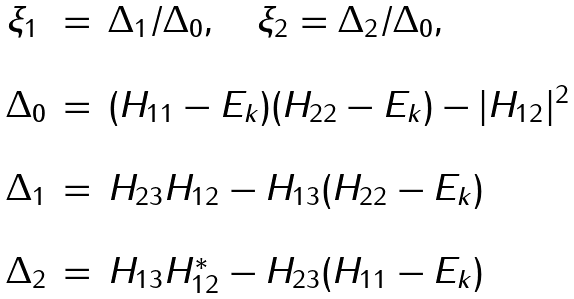Convert formula to latex. <formula><loc_0><loc_0><loc_500><loc_500>\begin{array} { l c l } \xi _ { 1 } & = & \Delta _ { 1 } / \Delta _ { 0 } , \quad \xi _ { 2 } = \Delta _ { 2 } / \Delta _ { 0 } , \\ & & \\ \Delta _ { 0 } & = & ( H _ { 1 1 } - E _ { k } ) ( H _ { 2 2 } - E _ { k } ) - | H _ { 1 2 } | ^ { 2 } \\ & & \\ \Delta _ { 1 } & = & H _ { 2 3 } H _ { 1 2 } - H _ { 1 3 } ( H _ { 2 2 } - E _ { k } ) \\ & & \\ \Delta _ { 2 } & = & H _ { 1 3 } H _ { 1 2 } ^ { * } - H _ { 2 3 } ( H _ { 1 1 } - E _ { k } ) \end{array}</formula> 